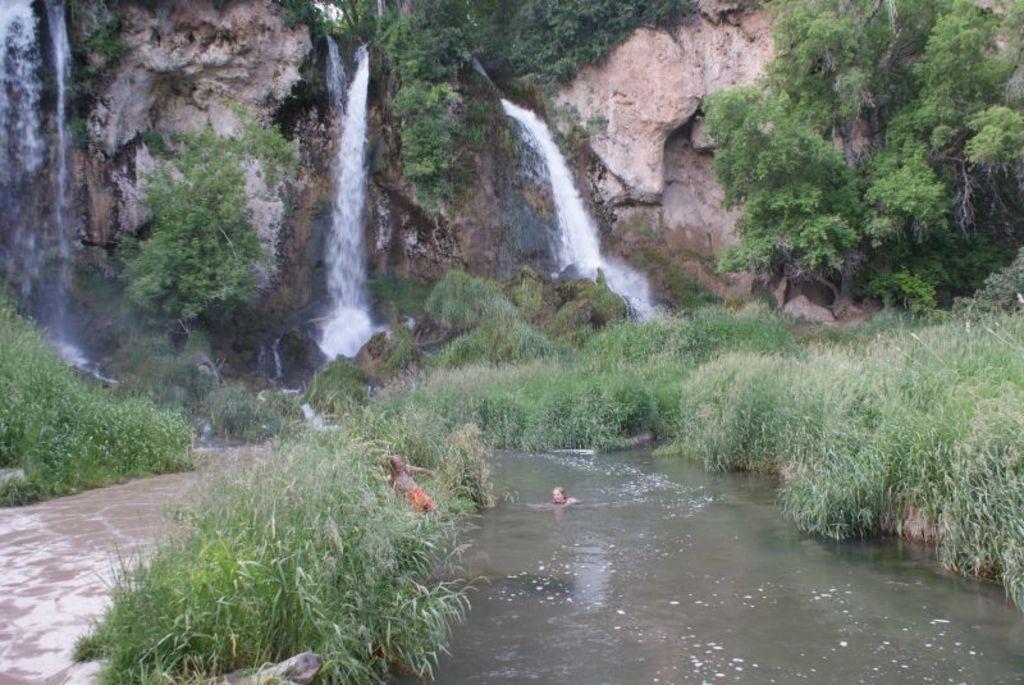How would you summarize this image in a sentence or two? In this image we can see plants, water and a person is partially in the water and another person is at the bushes. In the background we can see plants, trees, waterfall and cliff. 